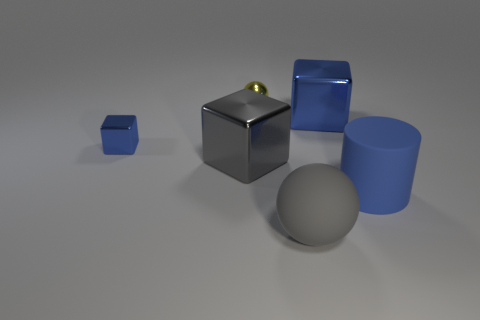Subtract all blue metal cubes. How many cubes are left? 1 Add 3 small blue objects. How many objects exist? 9 Subtract all balls. How many objects are left? 4 Add 6 blue matte things. How many blue matte things exist? 7 Subtract 0 yellow cylinders. How many objects are left? 6 Subtract all big blue shiny cubes. Subtract all large shiny things. How many objects are left? 3 Add 1 large blue things. How many large blue things are left? 3 